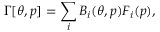<formula> <loc_0><loc_0><loc_500><loc_500>\Gamma [ \theta , p ] = \sum _ { i } B _ { i } ( \theta , p ) F _ { i } ( p ) ,</formula> 